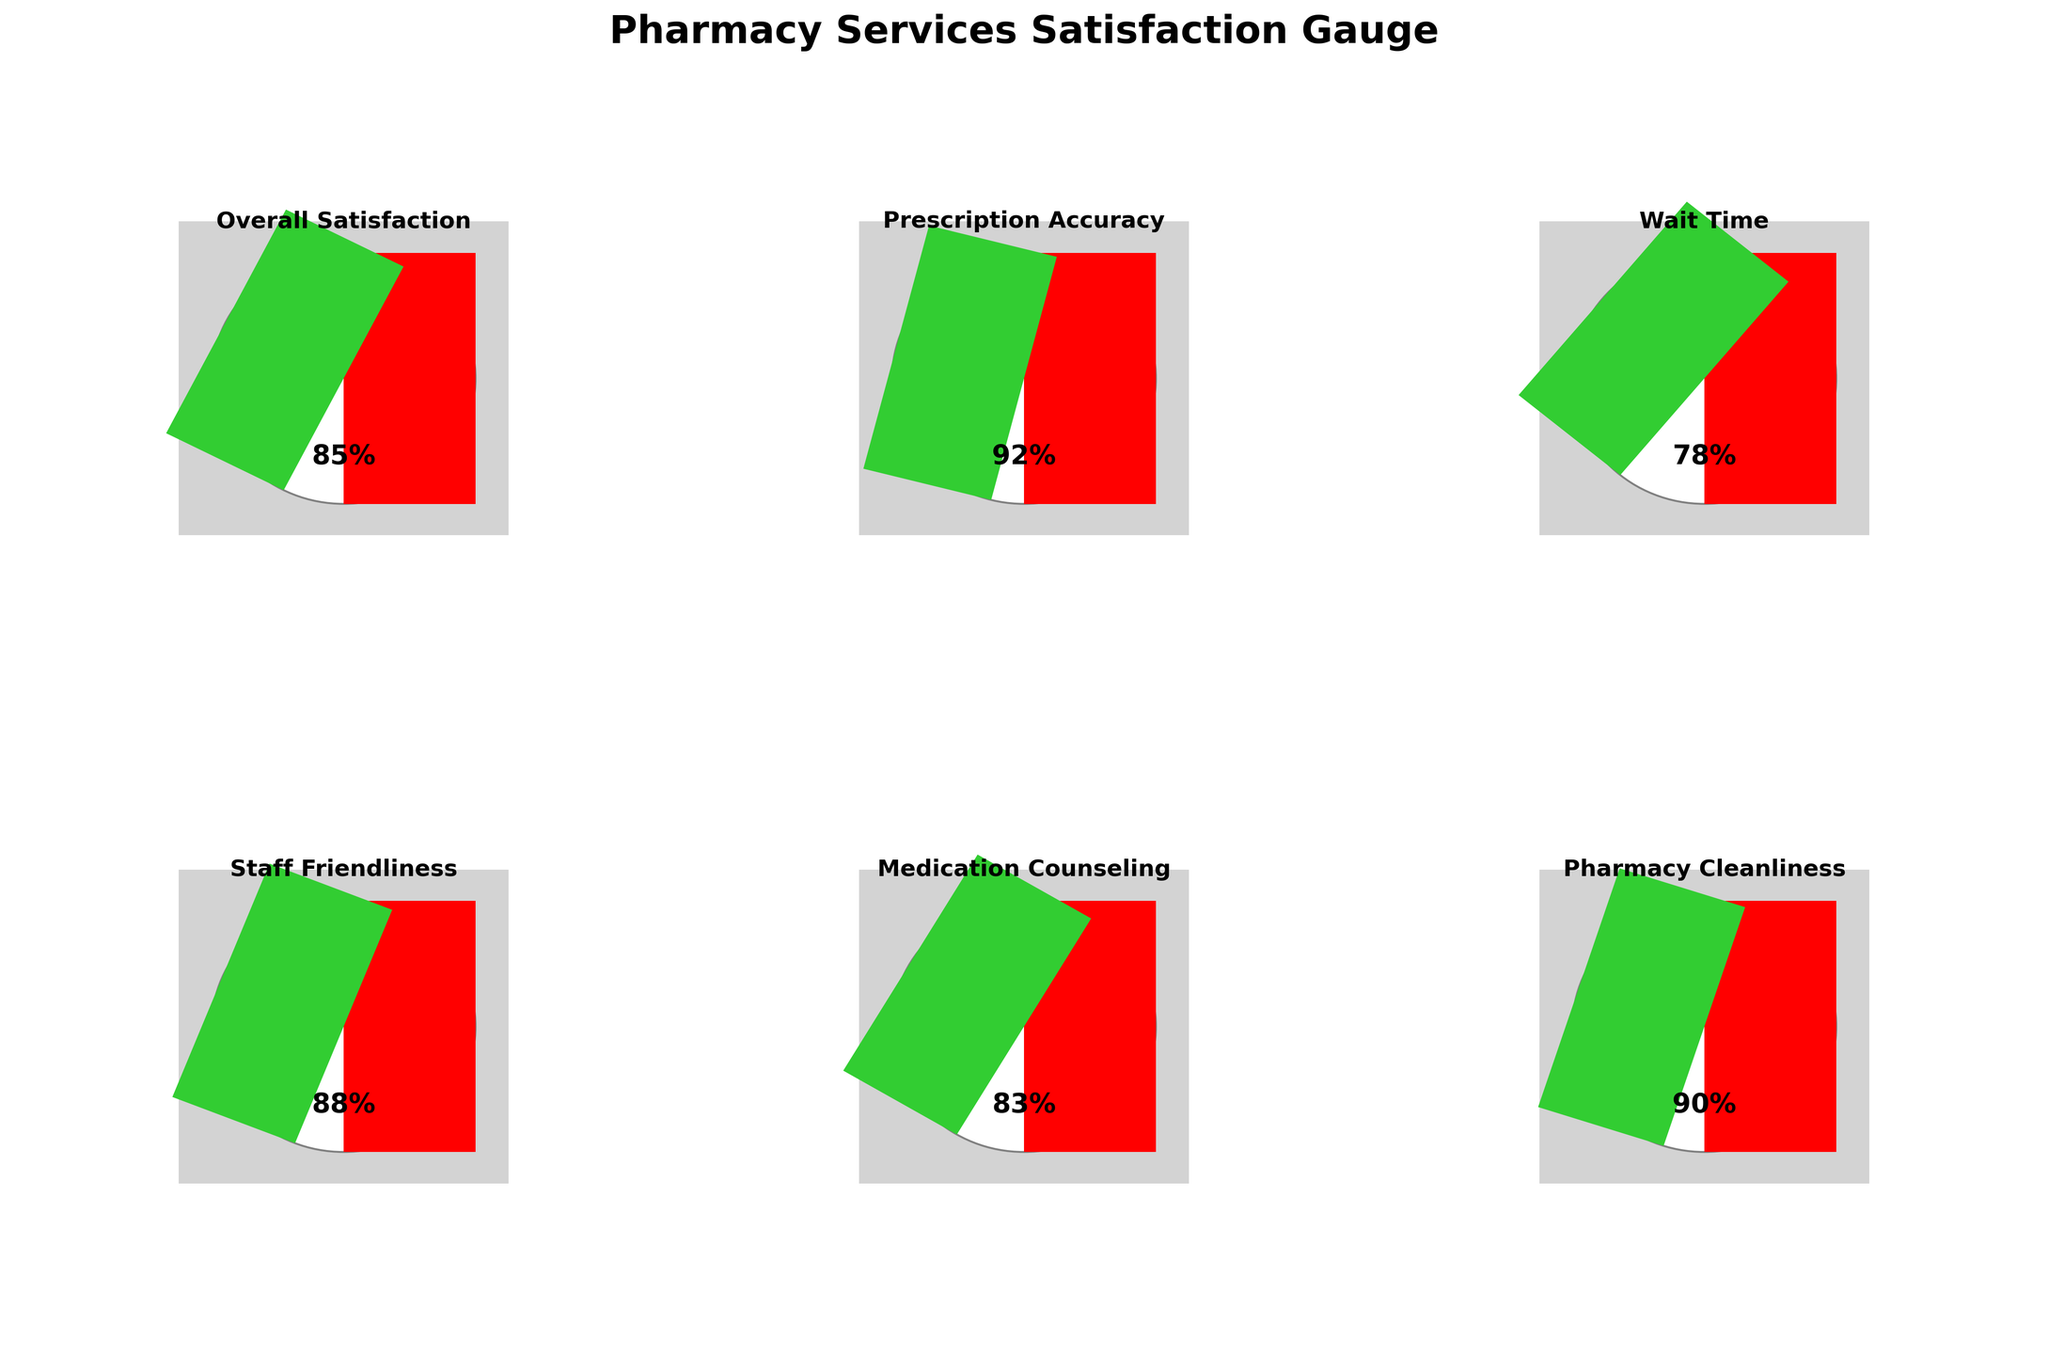what is the title of the figure? The title is displayed at the top of the figure, summarizing what the figure represents.
Answer: Pharmacy Services Satisfaction Gauge what is the satisfaction score for Prescription Accuracy? Look at the gauge corresponding to "Prescription Accuracy" and note the value indicated.
Answer: 92% Which individual metric has the lowest satisfaction score? Compare the values for each metric and identify the one with the smallest value.
Answer: Wait Time What is the average satisfaction score across all metrics? Sum the scores (85+92+78+88+83+90) and divide by the number of metrics (6). The sum is 516, and the average is 516/6.
Answer: 86% How does the satisfaction score for Staff Friendliness compare to Medication Counseling? Compare the values for "Staff Friendliness" and "Medication Counseling". Staff Friendliness has a score of 88% and Medication Counseling has a score of 83%, so Staff Friendliness is higher.
Answer: Staff Friendliness is higher Which metric's satisfaction score is closest to 85%? Compare each metric's satisfaction score to 85% and identify the closest one. "Overall Satisfaction" has a score of 85%, which is exactly 85%.
Answer: Overall Satisfaction Is the satisfaction score for Pharmacy Cleanliness above or below the overall average? Calculate the average satisfaction score as in a previous question (86%) and compare it to the score for Pharmacy Cleanliness (90%).
Answer: Above If Wait Time had a satisfaction score of 82, what would be the new average satisfaction score? Replace the Wait Time score with 82 and recalculate the average: sum(85+92+82+88+83+90)/6 = 520/6 = 86.67. The new average would be 86.67%.
Answer: 86.67% For which metrics is the satisfaction score above 90%? Identify metrics where the score is greater than 90%. In this case, Prescription Accuracy has a score of 92%.
Answer: Prescription Accuracy What can be inferred about the least and most satisfactory areas of pharmacy services based on the gauge chart? The least satisfactory area is "Wait Time" with a score of 78%, and the most satisfactory area is "Prescription Accuracy" with a score of 92%. This suggests that customers are less satisfied with how long they wait and most satisfied with the accuracy of their prescriptions.
Answer: Wait Time is least satisfactory, Prescription Accuracy is most satisfactory 